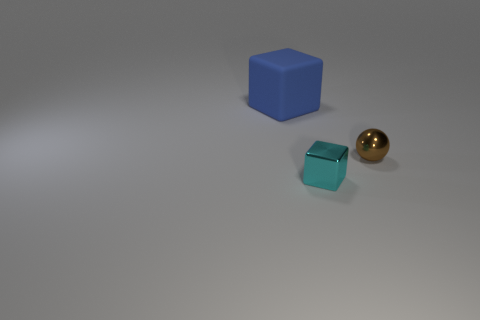Subtract 1 balls. How many balls are left? 0 Add 3 matte cylinders. How many objects exist? 6 Subtract all cyan spheres. Subtract all blue cubes. How many spheres are left? 1 Subtract all cyan cylinders. How many yellow balls are left? 0 Subtract all small cyan blocks. Subtract all tiny cyan metal things. How many objects are left? 1 Add 1 tiny cyan shiny things. How many tiny cyan shiny things are left? 2 Add 2 tiny cyan cubes. How many tiny cyan cubes exist? 3 Subtract 0 yellow balls. How many objects are left? 3 Subtract all blocks. How many objects are left? 1 